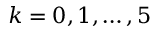<formula> <loc_0><loc_0><loc_500><loc_500>k = 0 , 1 , \dots , 5</formula> 